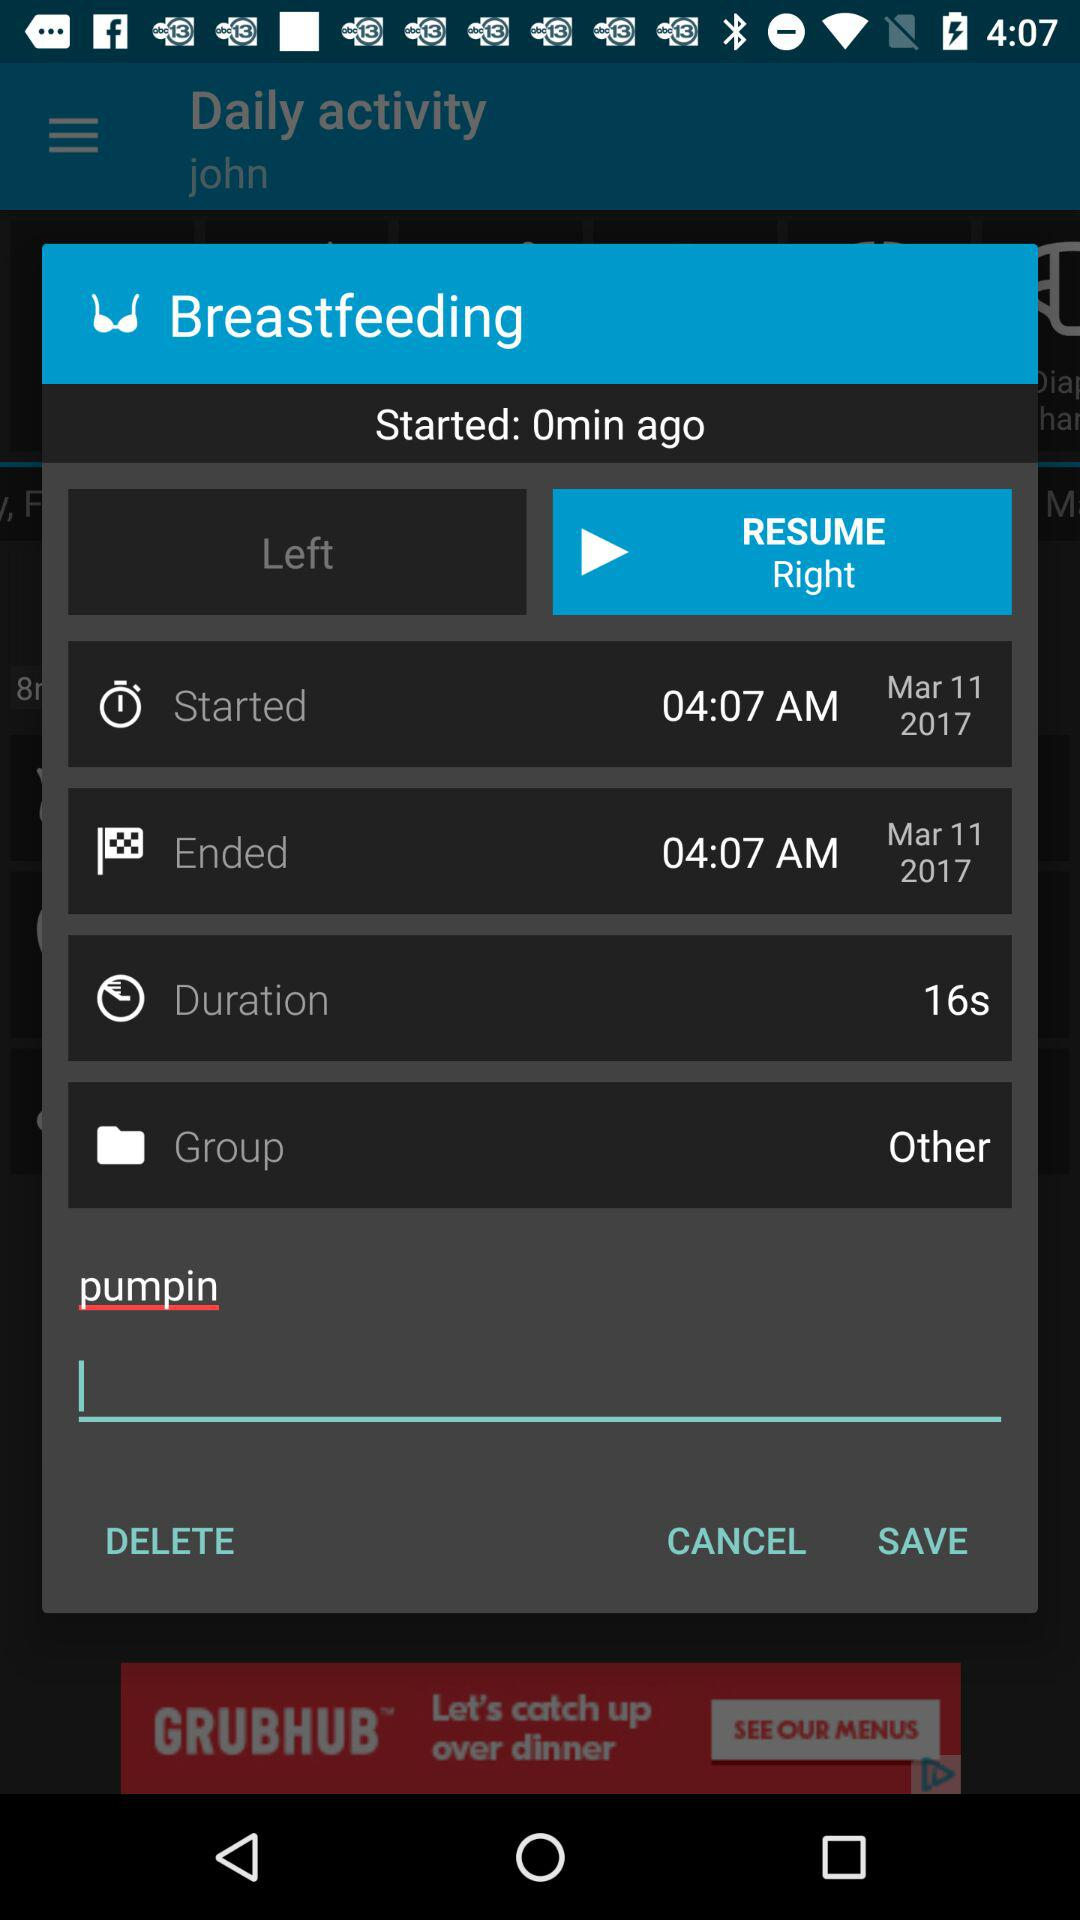When was breastfeeding ended? Breastfeeding was ended on March 11, 2017 at 04:07 AM. 